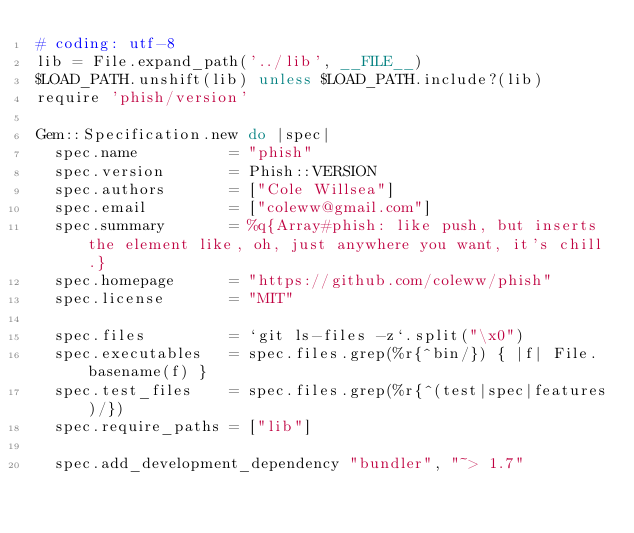<code> <loc_0><loc_0><loc_500><loc_500><_Ruby_># coding: utf-8
lib = File.expand_path('../lib', __FILE__)
$LOAD_PATH.unshift(lib) unless $LOAD_PATH.include?(lib)
require 'phish/version'

Gem::Specification.new do |spec|
  spec.name          = "phish"
  spec.version       = Phish::VERSION
  spec.authors       = ["Cole Willsea"]
  spec.email         = ["coleww@gmail.com"]
  spec.summary       = %q{Array#phish: like push, but inserts the element like, oh, just anywhere you want, it's chill.}
  spec.homepage      = "https://github.com/coleww/phish"
  spec.license       = "MIT"

  spec.files         = `git ls-files -z`.split("\x0")
  spec.executables   = spec.files.grep(%r{^bin/}) { |f| File.basename(f) }
  spec.test_files    = spec.files.grep(%r{^(test|spec|features)/})
  spec.require_paths = ["lib"]

  spec.add_development_dependency "bundler", "~> 1.7"</code> 